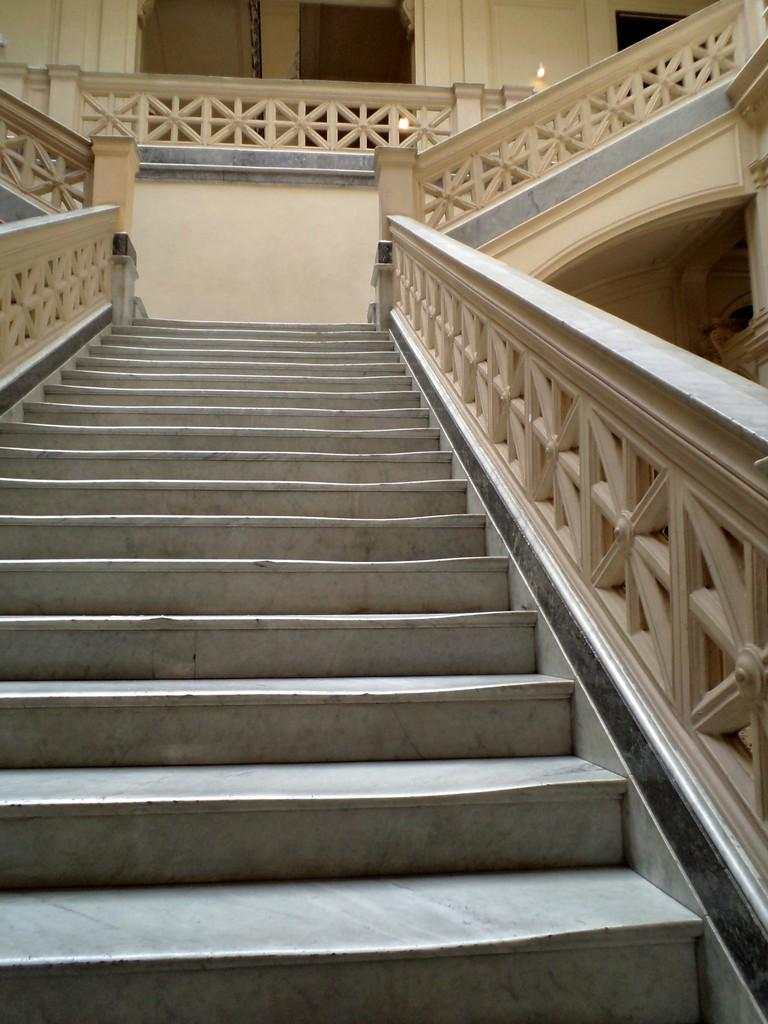What is the main feature in the center of the image? There is a staircase in the center of the image. What safety feature is present on the staircase? The staircase has a railing. What can be seen in the background of the image? There is a door and a wall in the background of the image. What type of clover is growing on the staircase in the image? There is no clover present in the image; the focus is on the staircase and its features. 